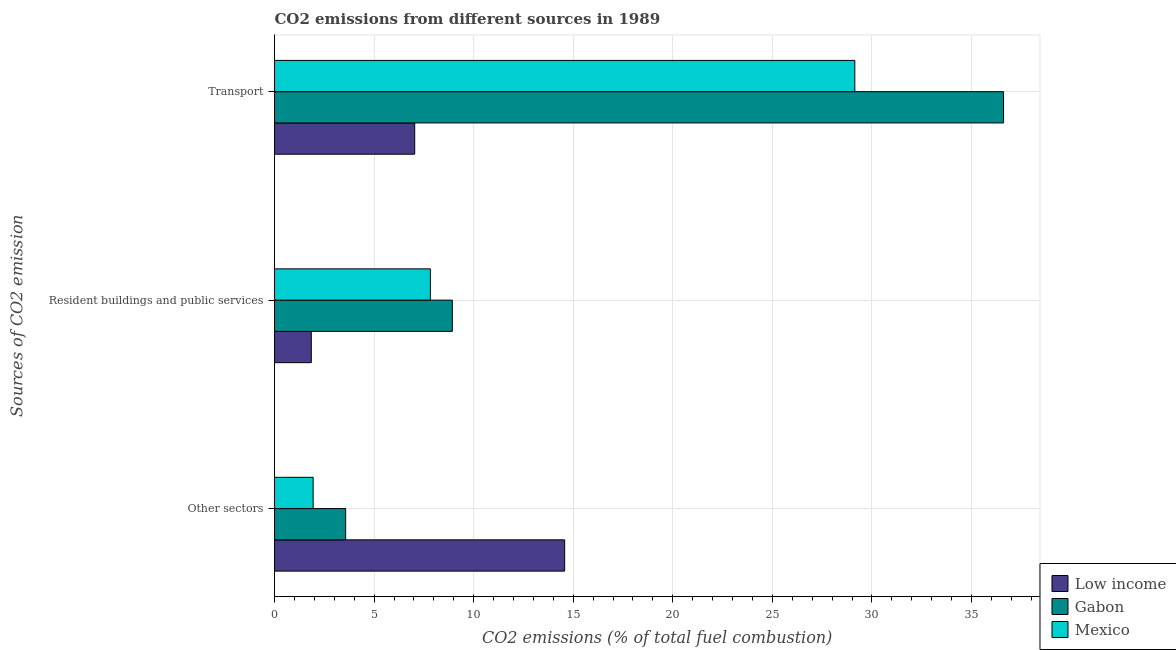Are the number of bars per tick equal to the number of legend labels?
Offer a terse response. Yes. Are the number of bars on each tick of the Y-axis equal?
Keep it short and to the point. Yes. How many bars are there on the 1st tick from the top?
Offer a terse response. 3. What is the label of the 1st group of bars from the top?
Your answer should be compact. Transport. What is the percentage of co2 emissions from transport in Low income?
Give a very brief answer. 7.04. Across all countries, what is the maximum percentage of co2 emissions from transport?
Keep it short and to the point. 36.61. Across all countries, what is the minimum percentage of co2 emissions from other sectors?
Your response must be concise. 1.94. In which country was the percentage of co2 emissions from transport maximum?
Offer a terse response. Gabon. What is the total percentage of co2 emissions from resident buildings and public services in the graph?
Ensure brevity in your answer.  18.6. What is the difference between the percentage of co2 emissions from transport in Low income and that in Mexico?
Offer a very short reply. -22.1. What is the difference between the percentage of co2 emissions from transport in Mexico and the percentage of co2 emissions from other sectors in Gabon?
Your answer should be compact. 25.57. What is the average percentage of co2 emissions from transport per country?
Give a very brief answer. 24.26. What is the difference between the percentage of co2 emissions from resident buildings and public services and percentage of co2 emissions from other sectors in Mexico?
Offer a very short reply. 5.89. What is the ratio of the percentage of co2 emissions from transport in Gabon to that in Mexico?
Your answer should be very brief. 1.26. Is the difference between the percentage of co2 emissions from transport in Mexico and Gabon greater than the difference between the percentage of co2 emissions from other sectors in Mexico and Gabon?
Offer a terse response. No. What is the difference between the highest and the second highest percentage of co2 emissions from other sectors?
Offer a very short reply. 11. What is the difference between the highest and the lowest percentage of co2 emissions from transport?
Give a very brief answer. 29.57. What does the 1st bar from the top in Other sectors represents?
Your answer should be compact. Mexico. What does the 3rd bar from the bottom in Other sectors represents?
Your response must be concise. Mexico. Are all the bars in the graph horizontal?
Give a very brief answer. Yes. How many legend labels are there?
Your answer should be very brief. 3. What is the title of the graph?
Offer a terse response. CO2 emissions from different sources in 1989. Does "European Union" appear as one of the legend labels in the graph?
Offer a terse response. No. What is the label or title of the X-axis?
Provide a short and direct response. CO2 emissions (% of total fuel combustion). What is the label or title of the Y-axis?
Offer a terse response. Sources of CO2 emission. What is the CO2 emissions (% of total fuel combustion) in Low income in Other sectors?
Your response must be concise. 14.57. What is the CO2 emissions (% of total fuel combustion) of Gabon in Other sectors?
Keep it short and to the point. 3.57. What is the CO2 emissions (% of total fuel combustion) in Mexico in Other sectors?
Give a very brief answer. 1.94. What is the CO2 emissions (% of total fuel combustion) of Low income in Resident buildings and public services?
Offer a very short reply. 1.85. What is the CO2 emissions (% of total fuel combustion) of Gabon in Resident buildings and public services?
Make the answer very short. 8.93. What is the CO2 emissions (% of total fuel combustion) in Mexico in Resident buildings and public services?
Give a very brief answer. 7.83. What is the CO2 emissions (% of total fuel combustion) of Low income in Transport?
Your answer should be compact. 7.04. What is the CO2 emissions (% of total fuel combustion) of Gabon in Transport?
Give a very brief answer. 36.61. What is the CO2 emissions (% of total fuel combustion) in Mexico in Transport?
Your response must be concise. 29.14. Across all Sources of CO2 emission, what is the maximum CO2 emissions (% of total fuel combustion) of Low income?
Keep it short and to the point. 14.57. Across all Sources of CO2 emission, what is the maximum CO2 emissions (% of total fuel combustion) in Gabon?
Your answer should be very brief. 36.61. Across all Sources of CO2 emission, what is the maximum CO2 emissions (% of total fuel combustion) in Mexico?
Make the answer very short. 29.14. Across all Sources of CO2 emission, what is the minimum CO2 emissions (% of total fuel combustion) of Low income?
Your answer should be compact. 1.85. Across all Sources of CO2 emission, what is the minimum CO2 emissions (% of total fuel combustion) of Gabon?
Make the answer very short. 3.57. Across all Sources of CO2 emission, what is the minimum CO2 emissions (% of total fuel combustion) of Mexico?
Your answer should be compact. 1.94. What is the total CO2 emissions (% of total fuel combustion) of Low income in the graph?
Your answer should be very brief. 23.45. What is the total CO2 emissions (% of total fuel combustion) of Gabon in the graph?
Keep it short and to the point. 49.11. What is the total CO2 emissions (% of total fuel combustion) of Mexico in the graph?
Give a very brief answer. 38.9. What is the difference between the CO2 emissions (% of total fuel combustion) in Low income in Other sectors and that in Resident buildings and public services?
Your answer should be very brief. 12.72. What is the difference between the CO2 emissions (% of total fuel combustion) of Gabon in Other sectors and that in Resident buildings and public services?
Your answer should be compact. -5.36. What is the difference between the CO2 emissions (% of total fuel combustion) in Mexico in Other sectors and that in Resident buildings and public services?
Provide a short and direct response. -5.89. What is the difference between the CO2 emissions (% of total fuel combustion) of Low income in Other sectors and that in Transport?
Keep it short and to the point. 7.53. What is the difference between the CO2 emissions (% of total fuel combustion) of Gabon in Other sectors and that in Transport?
Your response must be concise. -33.04. What is the difference between the CO2 emissions (% of total fuel combustion) of Mexico in Other sectors and that in Transport?
Keep it short and to the point. -27.2. What is the difference between the CO2 emissions (% of total fuel combustion) in Low income in Resident buildings and public services and that in Transport?
Make the answer very short. -5.19. What is the difference between the CO2 emissions (% of total fuel combustion) of Gabon in Resident buildings and public services and that in Transport?
Provide a succinct answer. -27.68. What is the difference between the CO2 emissions (% of total fuel combustion) in Mexico in Resident buildings and public services and that in Transport?
Give a very brief answer. -21.31. What is the difference between the CO2 emissions (% of total fuel combustion) of Low income in Other sectors and the CO2 emissions (% of total fuel combustion) of Gabon in Resident buildings and public services?
Your answer should be compact. 5.64. What is the difference between the CO2 emissions (% of total fuel combustion) in Low income in Other sectors and the CO2 emissions (% of total fuel combustion) in Mexico in Resident buildings and public services?
Offer a very short reply. 6.74. What is the difference between the CO2 emissions (% of total fuel combustion) of Gabon in Other sectors and the CO2 emissions (% of total fuel combustion) of Mexico in Resident buildings and public services?
Give a very brief answer. -4.25. What is the difference between the CO2 emissions (% of total fuel combustion) of Low income in Other sectors and the CO2 emissions (% of total fuel combustion) of Gabon in Transport?
Ensure brevity in your answer.  -22.04. What is the difference between the CO2 emissions (% of total fuel combustion) of Low income in Other sectors and the CO2 emissions (% of total fuel combustion) of Mexico in Transport?
Keep it short and to the point. -14.57. What is the difference between the CO2 emissions (% of total fuel combustion) in Gabon in Other sectors and the CO2 emissions (% of total fuel combustion) in Mexico in Transport?
Your answer should be compact. -25.57. What is the difference between the CO2 emissions (% of total fuel combustion) in Low income in Resident buildings and public services and the CO2 emissions (% of total fuel combustion) in Gabon in Transport?
Keep it short and to the point. -34.76. What is the difference between the CO2 emissions (% of total fuel combustion) in Low income in Resident buildings and public services and the CO2 emissions (% of total fuel combustion) in Mexico in Transport?
Offer a terse response. -27.29. What is the difference between the CO2 emissions (% of total fuel combustion) in Gabon in Resident buildings and public services and the CO2 emissions (% of total fuel combustion) in Mexico in Transport?
Give a very brief answer. -20.21. What is the average CO2 emissions (% of total fuel combustion) in Low income per Sources of CO2 emission?
Your response must be concise. 7.82. What is the average CO2 emissions (% of total fuel combustion) in Gabon per Sources of CO2 emission?
Offer a very short reply. 16.37. What is the average CO2 emissions (% of total fuel combustion) in Mexico per Sources of CO2 emission?
Offer a terse response. 12.97. What is the difference between the CO2 emissions (% of total fuel combustion) of Low income and CO2 emissions (% of total fuel combustion) of Gabon in Other sectors?
Offer a very short reply. 11. What is the difference between the CO2 emissions (% of total fuel combustion) of Low income and CO2 emissions (% of total fuel combustion) of Mexico in Other sectors?
Keep it short and to the point. 12.63. What is the difference between the CO2 emissions (% of total fuel combustion) in Gabon and CO2 emissions (% of total fuel combustion) in Mexico in Other sectors?
Your answer should be very brief. 1.63. What is the difference between the CO2 emissions (% of total fuel combustion) in Low income and CO2 emissions (% of total fuel combustion) in Gabon in Resident buildings and public services?
Give a very brief answer. -7.08. What is the difference between the CO2 emissions (% of total fuel combustion) in Low income and CO2 emissions (% of total fuel combustion) in Mexico in Resident buildings and public services?
Offer a very short reply. -5.98. What is the difference between the CO2 emissions (% of total fuel combustion) of Gabon and CO2 emissions (% of total fuel combustion) of Mexico in Resident buildings and public services?
Offer a terse response. 1.1. What is the difference between the CO2 emissions (% of total fuel combustion) of Low income and CO2 emissions (% of total fuel combustion) of Gabon in Transport?
Offer a terse response. -29.57. What is the difference between the CO2 emissions (% of total fuel combustion) of Low income and CO2 emissions (% of total fuel combustion) of Mexico in Transport?
Provide a succinct answer. -22.1. What is the difference between the CO2 emissions (% of total fuel combustion) in Gabon and CO2 emissions (% of total fuel combustion) in Mexico in Transport?
Give a very brief answer. 7.47. What is the ratio of the CO2 emissions (% of total fuel combustion) of Low income in Other sectors to that in Resident buildings and public services?
Your answer should be compact. 7.89. What is the ratio of the CO2 emissions (% of total fuel combustion) of Mexico in Other sectors to that in Resident buildings and public services?
Your response must be concise. 0.25. What is the ratio of the CO2 emissions (% of total fuel combustion) of Low income in Other sectors to that in Transport?
Ensure brevity in your answer.  2.07. What is the ratio of the CO2 emissions (% of total fuel combustion) of Gabon in Other sectors to that in Transport?
Your response must be concise. 0.1. What is the ratio of the CO2 emissions (% of total fuel combustion) in Mexico in Other sectors to that in Transport?
Your response must be concise. 0.07. What is the ratio of the CO2 emissions (% of total fuel combustion) in Low income in Resident buildings and public services to that in Transport?
Keep it short and to the point. 0.26. What is the ratio of the CO2 emissions (% of total fuel combustion) of Gabon in Resident buildings and public services to that in Transport?
Provide a succinct answer. 0.24. What is the ratio of the CO2 emissions (% of total fuel combustion) of Mexico in Resident buildings and public services to that in Transport?
Provide a short and direct response. 0.27. What is the difference between the highest and the second highest CO2 emissions (% of total fuel combustion) of Low income?
Make the answer very short. 7.53. What is the difference between the highest and the second highest CO2 emissions (% of total fuel combustion) of Gabon?
Keep it short and to the point. 27.68. What is the difference between the highest and the second highest CO2 emissions (% of total fuel combustion) in Mexico?
Offer a very short reply. 21.31. What is the difference between the highest and the lowest CO2 emissions (% of total fuel combustion) in Low income?
Your answer should be compact. 12.72. What is the difference between the highest and the lowest CO2 emissions (% of total fuel combustion) of Gabon?
Keep it short and to the point. 33.04. What is the difference between the highest and the lowest CO2 emissions (% of total fuel combustion) of Mexico?
Keep it short and to the point. 27.2. 